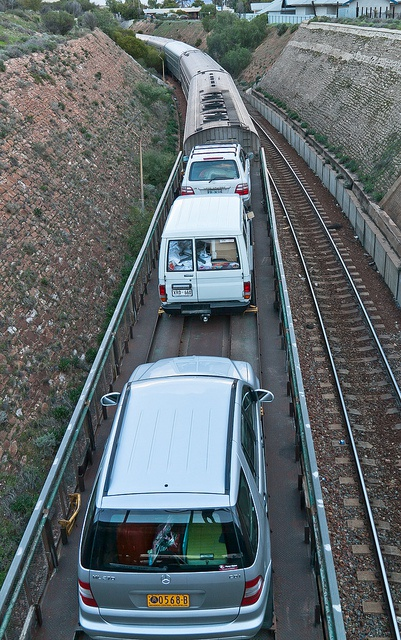Describe the objects in this image and their specific colors. I can see car in gray, lightblue, black, and blue tones, car in gray, white, lightblue, and black tones, train in gray, lightgray, and darkgray tones, and car in gray and lightgray tones in this image. 